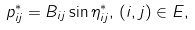<formula> <loc_0><loc_0><loc_500><loc_500>p ^ { * } _ { i j } = B _ { i j } \sin \eta _ { i j } ^ { * } , \, ( i , j ) \in E ,</formula> 